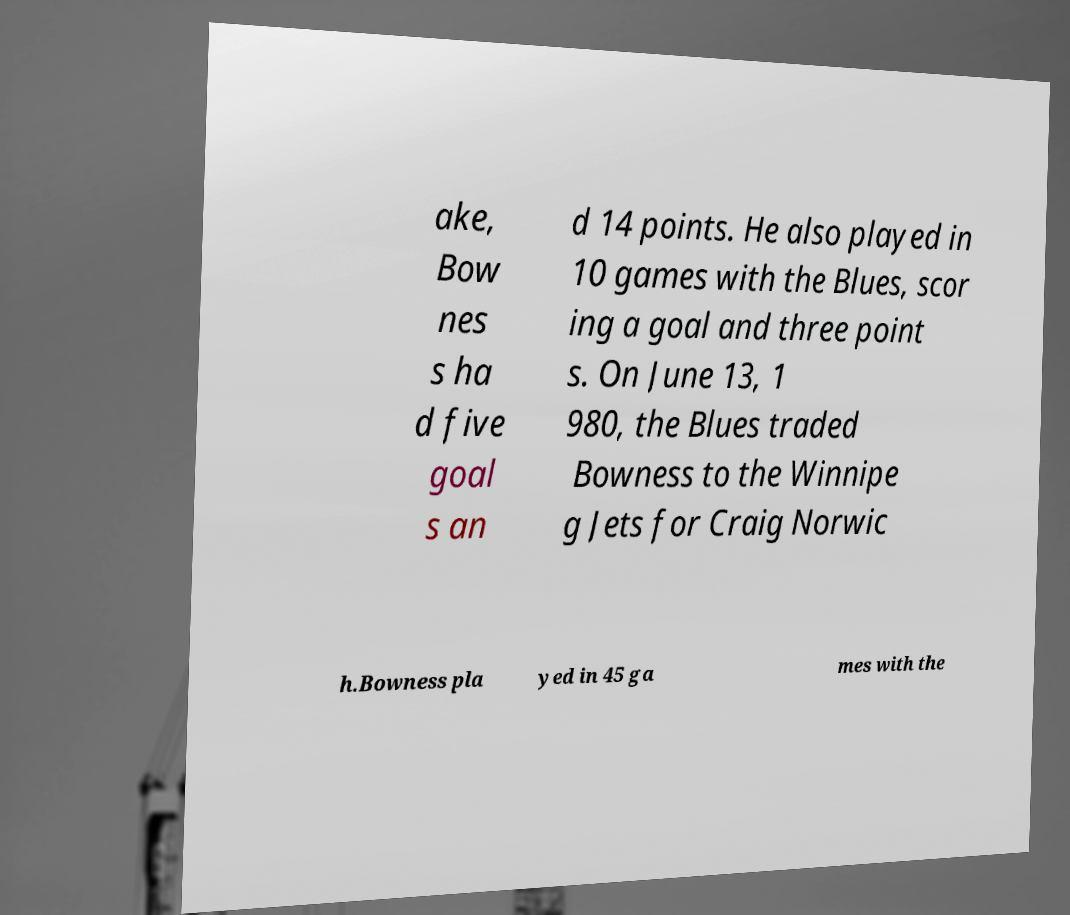For documentation purposes, I need the text within this image transcribed. Could you provide that? ake, Bow nes s ha d five goal s an d 14 points. He also played in 10 games with the Blues, scor ing a goal and three point s. On June 13, 1 980, the Blues traded Bowness to the Winnipe g Jets for Craig Norwic h.Bowness pla yed in 45 ga mes with the 